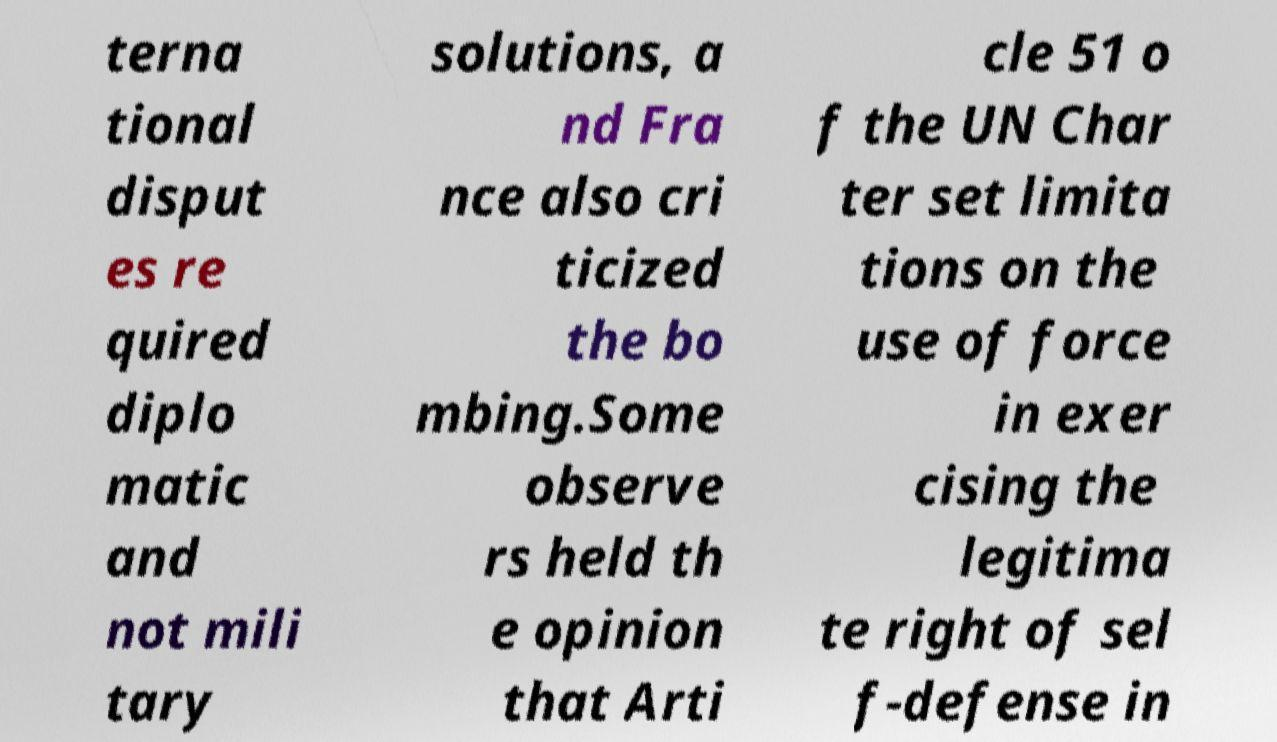For documentation purposes, I need the text within this image transcribed. Could you provide that? terna tional disput es re quired diplo matic and not mili tary solutions, a nd Fra nce also cri ticized the bo mbing.Some observe rs held th e opinion that Arti cle 51 o f the UN Char ter set limita tions on the use of force in exer cising the legitima te right of sel f-defense in 